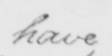Please provide the text content of this handwritten line. have 